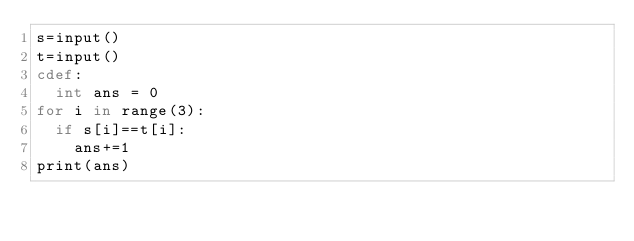<code> <loc_0><loc_0><loc_500><loc_500><_Cython_>s=input()
t=input()
cdef:
  int ans = 0
for i in range(3):
  if s[i]==t[i]:
    ans+=1
print(ans)</code> 